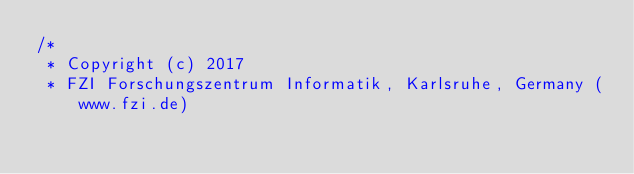<code> <loc_0><loc_0><loc_500><loc_500><_C++_>/*
 * Copyright (c) 2017
 * FZI Forschungszentrum Informatik, Karlsruhe, Germany (www.fzi.de)</code> 